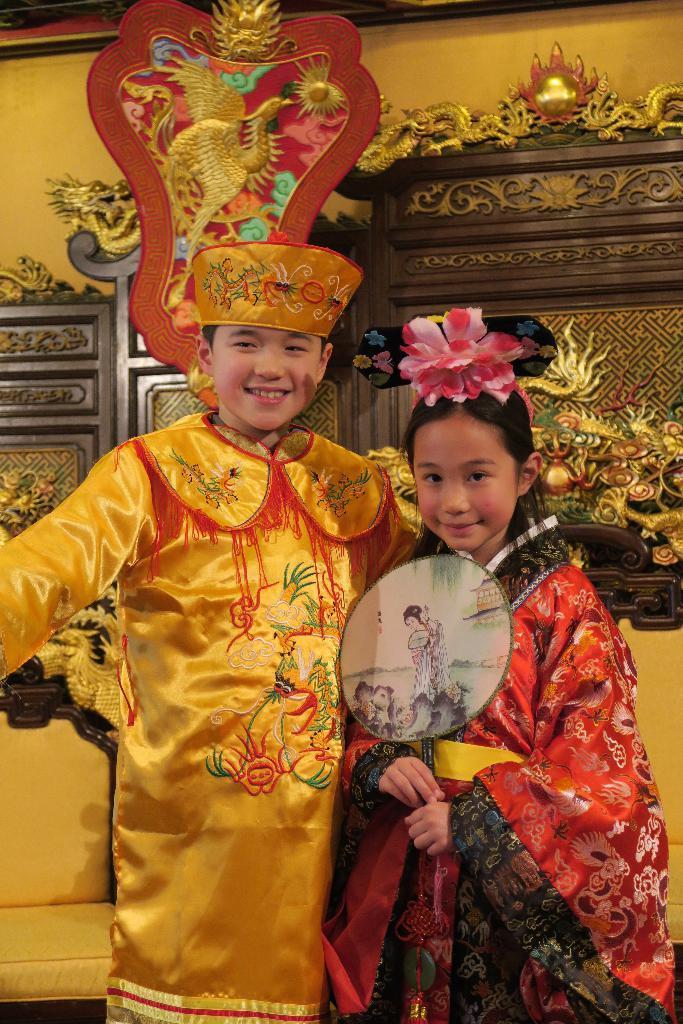How would you summarize this image in a sentence or two? In this picture we can see there are two kids in the traditional dress. Behind the kids there are chairs and a decorative wall. 